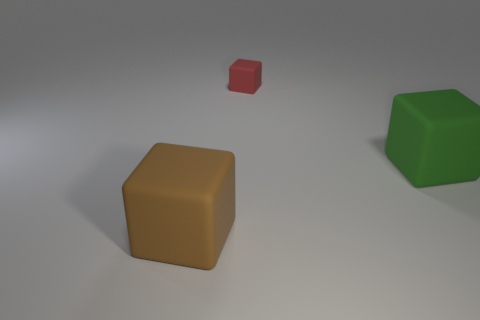Add 1 red objects. How many objects exist? 4 Add 1 large rubber cubes. How many large rubber cubes are left? 3 Add 3 tiny rubber cubes. How many tiny rubber cubes exist? 4 Subtract 1 red blocks. How many objects are left? 2 Subtract all small purple cubes. Subtract all big objects. How many objects are left? 1 